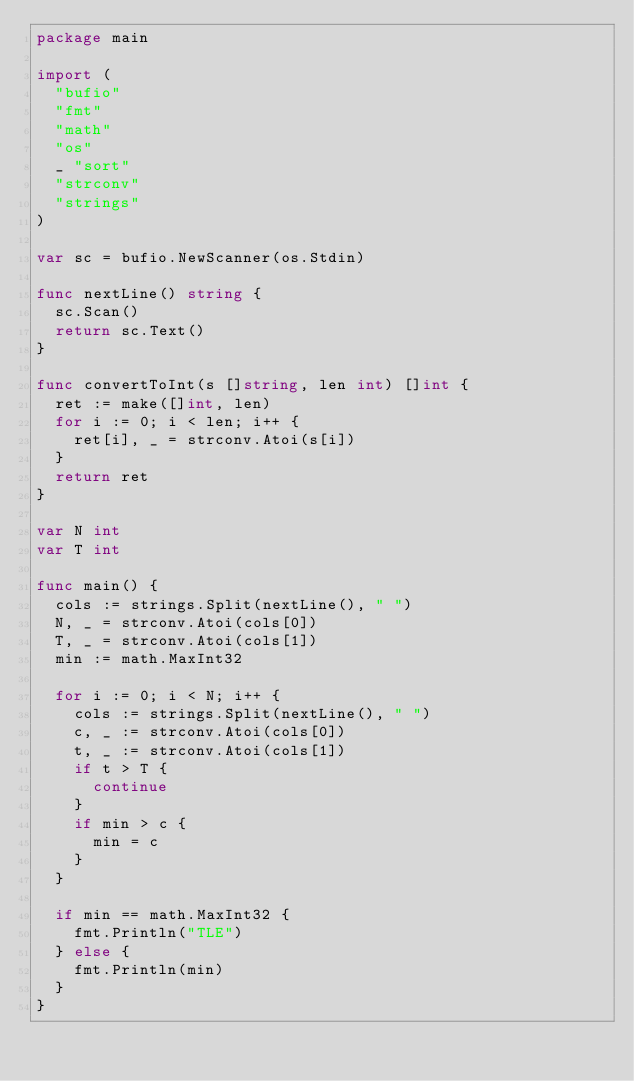<code> <loc_0><loc_0><loc_500><loc_500><_Go_>package main

import (
	"bufio"
	"fmt"
	"math"
	"os"
	_ "sort"
	"strconv"
	"strings"
)

var sc = bufio.NewScanner(os.Stdin)

func nextLine() string {
	sc.Scan()
	return sc.Text()
}

func convertToInt(s []string, len int) []int {
	ret := make([]int, len)
	for i := 0; i < len; i++ {
		ret[i], _ = strconv.Atoi(s[i])
	}
	return ret
}

var N int
var T int

func main() {
	cols := strings.Split(nextLine(), " ")
	N, _ = strconv.Atoi(cols[0])
	T, _ = strconv.Atoi(cols[1])
	min := math.MaxInt32

	for i := 0; i < N; i++ {
		cols := strings.Split(nextLine(), " ")
		c, _ := strconv.Atoi(cols[0])
		t, _ := strconv.Atoi(cols[1])
		if t > T {
			continue
		}
		if min > c {
			min = c
		}
	}

	if min == math.MaxInt32 {
		fmt.Println("TLE")
	} else {
		fmt.Println(min)
	}
}</code> 